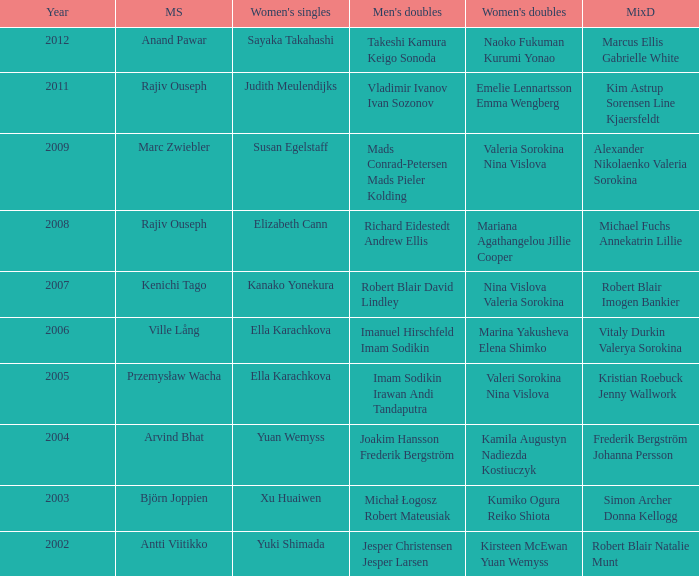What are the womens singles of naoko fukuman kurumi yonao? Sayaka Takahashi. 